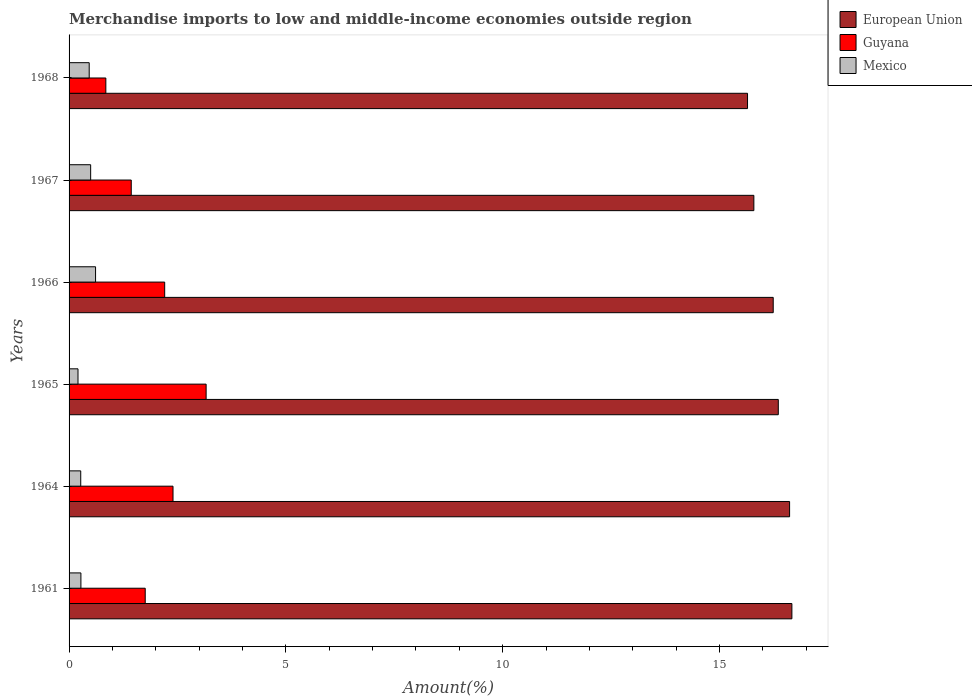How many different coloured bars are there?
Your answer should be compact. 3. How many groups of bars are there?
Your response must be concise. 6. Are the number of bars per tick equal to the number of legend labels?
Keep it short and to the point. Yes. Are the number of bars on each tick of the Y-axis equal?
Your answer should be very brief. Yes. How many bars are there on the 1st tick from the top?
Your response must be concise. 3. How many bars are there on the 5th tick from the bottom?
Give a very brief answer. 3. What is the label of the 4th group of bars from the top?
Make the answer very short. 1965. What is the percentage of amount earned from merchandise imports in Mexico in 1964?
Your answer should be compact. 0.27. Across all years, what is the maximum percentage of amount earned from merchandise imports in Guyana?
Offer a very short reply. 3.16. Across all years, what is the minimum percentage of amount earned from merchandise imports in Guyana?
Ensure brevity in your answer.  0.85. In which year was the percentage of amount earned from merchandise imports in Mexico minimum?
Ensure brevity in your answer.  1965. What is the total percentage of amount earned from merchandise imports in Mexico in the graph?
Give a very brief answer. 2.32. What is the difference between the percentage of amount earned from merchandise imports in European Union in 1964 and that in 1967?
Your answer should be very brief. 0.82. What is the difference between the percentage of amount earned from merchandise imports in Mexico in 1967 and the percentage of amount earned from merchandise imports in Guyana in 1965?
Provide a succinct answer. -2.66. What is the average percentage of amount earned from merchandise imports in European Union per year?
Offer a terse response. 16.22. In the year 1961, what is the difference between the percentage of amount earned from merchandise imports in Guyana and percentage of amount earned from merchandise imports in European Union?
Your response must be concise. -14.91. What is the ratio of the percentage of amount earned from merchandise imports in Mexico in 1964 to that in 1965?
Provide a short and direct response. 1.31. Is the percentage of amount earned from merchandise imports in Guyana in 1961 less than that in 1966?
Ensure brevity in your answer.  Yes. Is the difference between the percentage of amount earned from merchandise imports in Guyana in 1965 and 1968 greater than the difference between the percentage of amount earned from merchandise imports in European Union in 1965 and 1968?
Offer a very short reply. Yes. What is the difference between the highest and the second highest percentage of amount earned from merchandise imports in Mexico?
Your response must be concise. 0.11. What is the difference between the highest and the lowest percentage of amount earned from merchandise imports in European Union?
Your response must be concise. 1.02. In how many years, is the percentage of amount earned from merchandise imports in Guyana greater than the average percentage of amount earned from merchandise imports in Guyana taken over all years?
Ensure brevity in your answer.  3. Is the sum of the percentage of amount earned from merchandise imports in European Union in 1966 and 1967 greater than the maximum percentage of amount earned from merchandise imports in Mexico across all years?
Your response must be concise. Yes. What does the 2nd bar from the top in 1967 represents?
Your answer should be very brief. Guyana. Are all the bars in the graph horizontal?
Offer a terse response. Yes. Does the graph contain any zero values?
Offer a very short reply. No. Where does the legend appear in the graph?
Provide a short and direct response. Top right. What is the title of the graph?
Offer a very short reply. Merchandise imports to low and middle-income economies outside region. What is the label or title of the X-axis?
Provide a succinct answer. Amount(%). What is the Amount(%) of European Union in 1961?
Give a very brief answer. 16.67. What is the Amount(%) of Guyana in 1961?
Your answer should be compact. 1.76. What is the Amount(%) of Mexico in 1961?
Provide a short and direct response. 0.27. What is the Amount(%) in European Union in 1964?
Your answer should be very brief. 16.62. What is the Amount(%) in Guyana in 1964?
Make the answer very short. 2.4. What is the Amount(%) in Mexico in 1964?
Offer a very short reply. 0.27. What is the Amount(%) of European Union in 1965?
Offer a terse response. 16.36. What is the Amount(%) in Guyana in 1965?
Provide a short and direct response. 3.16. What is the Amount(%) in Mexico in 1965?
Your answer should be compact. 0.21. What is the Amount(%) in European Union in 1966?
Keep it short and to the point. 16.24. What is the Amount(%) in Guyana in 1966?
Make the answer very short. 2.21. What is the Amount(%) in Mexico in 1966?
Your answer should be very brief. 0.61. What is the Amount(%) of European Union in 1967?
Ensure brevity in your answer.  15.79. What is the Amount(%) in Guyana in 1967?
Ensure brevity in your answer.  1.43. What is the Amount(%) in Mexico in 1967?
Keep it short and to the point. 0.5. What is the Amount(%) in European Union in 1968?
Your response must be concise. 15.65. What is the Amount(%) in Guyana in 1968?
Make the answer very short. 0.85. What is the Amount(%) of Mexico in 1968?
Offer a terse response. 0.46. Across all years, what is the maximum Amount(%) of European Union?
Ensure brevity in your answer.  16.67. Across all years, what is the maximum Amount(%) in Guyana?
Ensure brevity in your answer.  3.16. Across all years, what is the maximum Amount(%) of Mexico?
Offer a very short reply. 0.61. Across all years, what is the minimum Amount(%) of European Union?
Make the answer very short. 15.65. Across all years, what is the minimum Amount(%) in Guyana?
Your answer should be compact. 0.85. Across all years, what is the minimum Amount(%) in Mexico?
Ensure brevity in your answer.  0.21. What is the total Amount(%) of European Union in the graph?
Make the answer very short. 97.33. What is the total Amount(%) in Guyana in the graph?
Provide a succinct answer. 11.8. What is the total Amount(%) in Mexico in the graph?
Your answer should be very brief. 2.32. What is the difference between the Amount(%) in European Union in 1961 and that in 1964?
Offer a very short reply. 0.05. What is the difference between the Amount(%) of Guyana in 1961 and that in 1964?
Keep it short and to the point. -0.64. What is the difference between the Amount(%) in Mexico in 1961 and that in 1964?
Offer a terse response. 0. What is the difference between the Amount(%) of European Union in 1961 and that in 1965?
Provide a short and direct response. 0.31. What is the difference between the Amount(%) in Guyana in 1961 and that in 1965?
Offer a very short reply. -1.4. What is the difference between the Amount(%) in Mexico in 1961 and that in 1965?
Ensure brevity in your answer.  0.07. What is the difference between the Amount(%) in European Union in 1961 and that in 1966?
Provide a short and direct response. 0.43. What is the difference between the Amount(%) of Guyana in 1961 and that in 1966?
Provide a succinct answer. -0.45. What is the difference between the Amount(%) in Mexico in 1961 and that in 1966?
Provide a succinct answer. -0.34. What is the difference between the Amount(%) in European Union in 1961 and that in 1967?
Keep it short and to the point. 0.88. What is the difference between the Amount(%) of Guyana in 1961 and that in 1967?
Offer a very short reply. 0.32. What is the difference between the Amount(%) of Mexico in 1961 and that in 1967?
Offer a terse response. -0.22. What is the difference between the Amount(%) of European Union in 1961 and that in 1968?
Your response must be concise. 1.02. What is the difference between the Amount(%) of Guyana in 1961 and that in 1968?
Your response must be concise. 0.91. What is the difference between the Amount(%) in Mexico in 1961 and that in 1968?
Ensure brevity in your answer.  -0.19. What is the difference between the Amount(%) of European Union in 1964 and that in 1965?
Ensure brevity in your answer.  0.26. What is the difference between the Amount(%) in Guyana in 1964 and that in 1965?
Make the answer very short. -0.76. What is the difference between the Amount(%) in Mexico in 1964 and that in 1965?
Provide a short and direct response. 0.06. What is the difference between the Amount(%) in European Union in 1964 and that in 1966?
Make the answer very short. 0.38. What is the difference between the Amount(%) in Guyana in 1964 and that in 1966?
Provide a short and direct response. 0.19. What is the difference between the Amount(%) of Mexico in 1964 and that in 1966?
Offer a terse response. -0.34. What is the difference between the Amount(%) in European Union in 1964 and that in 1967?
Keep it short and to the point. 0.82. What is the difference between the Amount(%) in Guyana in 1964 and that in 1967?
Your answer should be very brief. 0.96. What is the difference between the Amount(%) in Mexico in 1964 and that in 1967?
Give a very brief answer. -0.23. What is the difference between the Amount(%) in European Union in 1964 and that in 1968?
Keep it short and to the point. 0.97. What is the difference between the Amount(%) of Guyana in 1964 and that in 1968?
Your answer should be compact. 1.55. What is the difference between the Amount(%) of Mexico in 1964 and that in 1968?
Make the answer very short. -0.2. What is the difference between the Amount(%) in European Union in 1965 and that in 1966?
Keep it short and to the point. 0.12. What is the difference between the Amount(%) of Guyana in 1965 and that in 1966?
Provide a succinct answer. 0.96. What is the difference between the Amount(%) in Mexico in 1965 and that in 1966?
Your response must be concise. -0.4. What is the difference between the Amount(%) in European Union in 1965 and that in 1967?
Ensure brevity in your answer.  0.56. What is the difference between the Amount(%) of Guyana in 1965 and that in 1967?
Make the answer very short. 1.73. What is the difference between the Amount(%) in Mexico in 1965 and that in 1967?
Ensure brevity in your answer.  -0.29. What is the difference between the Amount(%) in European Union in 1965 and that in 1968?
Your response must be concise. 0.71. What is the difference between the Amount(%) of Guyana in 1965 and that in 1968?
Make the answer very short. 2.31. What is the difference between the Amount(%) in Mexico in 1965 and that in 1968?
Your answer should be very brief. -0.26. What is the difference between the Amount(%) in European Union in 1966 and that in 1967?
Make the answer very short. 0.45. What is the difference between the Amount(%) of Guyana in 1966 and that in 1967?
Provide a succinct answer. 0.77. What is the difference between the Amount(%) in Mexico in 1966 and that in 1967?
Your response must be concise. 0.11. What is the difference between the Amount(%) in European Union in 1966 and that in 1968?
Offer a terse response. 0.59. What is the difference between the Amount(%) in Guyana in 1966 and that in 1968?
Provide a succinct answer. 1.36. What is the difference between the Amount(%) in Mexico in 1966 and that in 1968?
Keep it short and to the point. 0.15. What is the difference between the Amount(%) in European Union in 1967 and that in 1968?
Provide a succinct answer. 0.15. What is the difference between the Amount(%) of Guyana in 1967 and that in 1968?
Ensure brevity in your answer.  0.59. What is the difference between the Amount(%) in Mexico in 1967 and that in 1968?
Your response must be concise. 0.03. What is the difference between the Amount(%) of European Union in 1961 and the Amount(%) of Guyana in 1964?
Your response must be concise. 14.27. What is the difference between the Amount(%) of European Union in 1961 and the Amount(%) of Mexico in 1964?
Provide a succinct answer. 16.4. What is the difference between the Amount(%) of Guyana in 1961 and the Amount(%) of Mexico in 1964?
Provide a short and direct response. 1.49. What is the difference between the Amount(%) in European Union in 1961 and the Amount(%) in Guyana in 1965?
Offer a very short reply. 13.51. What is the difference between the Amount(%) in European Union in 1961 and the Amount(%) in Mexico in 1965?
Your answer should be very brief. 16.47. What is the difference between the Amount(%) of Guyana in 1961 and the Amount(%) of Mexico in 1965?
Ensure brevity in your answer.  1.55. What is the difference between the Amount(%) of European Union in 1961 and the Amount(%) of Guyana in 1966?
Provide a short and direct response. 14.47. What is the difference between the Amount(%) in European Union in 1961 and the Amount(%) in Mexico in 1966?
Offer a terse response. 16.06. What is the difference between the Amount(%) of Guyana in 1961 and the Amount(%) of Mexico in 1966?
Ensure brevity in your answer.  1.15. What is the difference between the Amount(%) in European Union in 1961 and the Amount(%) in Guyana in 1967?
Offer a very short reply. 15.24. What is the difference between the Amount(%) of European Union in 1961 and the Amount(%) of Mexico in 1967?
Offer a terse response. 16.17. What is the difference between the Amount(%) of Guyana in 1961 and the Amount(%) of Mexico in 1967?
Provide a succinct answer. 1.26. What is the difference between the Amount(%) in European Union in 1961 and the Amount(%) in Guyana in 1968?
Offer a very short reply. 15.82. What is the difference between the Amount(%) of European Union in 1961 and the Amount(%) of Mexico in 1968?
Keep it short and to the point. 16.21. What is the difference between the Amount(%) in Guyana in 1961 and the Amount(%) in Mexico in 1968?
Your answer should be very brief. 1.29. What is the difference between the Amount(%) in European Union in 1964 and the Amount(%) in Guyana in 1965?
Keep it short and to the point. 13.46. What is the difference between the Amount(%) of European Union in 1964 and the Amount(%) of Mexico in 1965?
Your answer should be compact. 16.41. What is the difference between the Amount(%) of Guyana in 1964 and the Amount(%) of Mexico in 1965?
Provide a succinct answer. 2.19. What is the difference between the Amount(%) of European Union in 1964 and the Amount(%) of Guyana in 1966?
Provide a short and direct response. 14.41. What is the difference between the Amount(%) in European Union in 1964 and the Amount(%) in Mexico in 1966?
Keep it short and to the point. 16.01. What is the difference between the Amount(%) of Guyana in 1964 and the Amount(%) of Mexico in 1966?
Your response must be concise. 1.79. What is the difference between the Amount(%) in European Union in 1964 and the Amount(%) in Guyana in 1967?
Your answer should be compact. 15.18. What is the difference between the Amount(%) of European Union in 1964 and the Amount(%) of Mexico in 1967?
Your answer should be compact. 16.12. What is the difference between the Amount(%) in Guyana in 1964 and the Amount(%) in Mexico in 1967?
Offer a very short reply. 1.9. What is the difference between the Amount(%) in European Union in 1964 and the Amount(%) in Guyana in 1968?
Keep it short and to the point. 15.77. What is the difference between the Amount(%) in European Union in 1964 and the Amount(%) in Mexico in 1968?
Keep it short and to the point. 16.15. What is the difference between the Amount(%) in Guyana in 1964 and the Amount(%) in Mexico in 1968?
Your answer should be compact. 1.93. What is the difference between the Amount(%) in European Union in 1965 and the Amount(%) in Guyana in 1966?
Offer a terse response. 14.15. What is the difference between the Amount(%) in European Union in 1965 and the Amount(%) in Mexico in 1966?
Offer a terse response. 15.75. What is the difference between the Amount(%) in Guyana in 1965 and the Amount(%) in Mexico in 1966?
Your response must be concise. 2.55. What is the difference between the Amount(%) in European Union in 1965 and the Amount(%) in Guyana in 1967?
Keep it short and to the point. 14.92. What is the difference between the Amount(%) in European Union in 1965 and the Amount(%) in Mexico in 1967?
Make the answer very short. 15.86. What is the difference between the Amount(%) of Guyana in 1965 and the Amount(%) of Mexico in 1967?
Make the answer very short. 2.66. What is the difference between the Amount(%) of European Union in 1965 and the Amount(%) of Guyana in 1968?
Ensure brevity in your answer.  15.51. What is the difference between the Amount(%) of European Union in 1965 and the Amount(%) of Mexico in 1968?
Provide a succinct answer. 15.89. What is the difference between the Amount(%) of Guyana in 1965 and the Amount(%) of Mexico in 1968?
Offer a very short reply. 2.7. What is the difference between the Amount(%) in European Union in 1966 and the Amount(%) in Guyana in 1967?
Offer a very short reply. 14.81. What is the difference between the Amount(%) of European Union in 1966 and the Amount(%) of Mexico in 1967?
Your answer should be compact. 15.74. What is the difference between the Amount(%) of Guyana in 1966 and the Amount(%) of Mexico in 1967?
Your answer should be very brief. 1.71. What is the difference between the Amount(%) in European Union in 1966 and the Amount(%) in Guyana in 1968?
Make the answer very short. 15.39. What is the difference between the Amount(%) of European Union in 1966 and the Amount(%) of Mexico in 1968?
Provide a succinct answer. 15.78. What is the difference between the Amount(%) of Guyana in 1966 and the Amount(%) of Mexico in 1968?
Provide a short and direct response. 1.74. What is the difference between the Amount(%) in European Union in 1967 and the Amount(%) in Guyana in 1968?
Your answer should be compact. 14.95. What is the difference between the Amount(%) of European Union in 1967 and the Amount(%) of Mexico in 1968?
Your response must be concise. 15.33. What is the difference between the Amount(%) of Guyana in 1967 and the Amount(%) of Mexico in 1968?
Make the answer very short. 0.97. What is the average Amount(%) of European Union per year?
Keep it short and to the point. 16.22. What is the average Amount(%) in Guyana per year?
Provide a succinct answer. 1.97. What is the average Amount(%) in Mexico per year?
Make the answer very short. 0.39. In the year 1961, what is the difference between the Amount(%) in European Union and Amount(%) in Guyana?
Provide a short and direct response. 14.91. In the year 1961, what is the difference between the Amount(%) of European Union and Amount(%) of Mexico?
Your answer should be compact. 16.4. In the year 1961, what is the difference between the Amount(%) in Guyana and Amount(%) in Mexico?
Your answer should be very brief. 1.48. In the year 1964, what is the difference between the Amount(%) of European Union and Amount(%) of Guyana?
Provide a short and direct response. 14.22. In the year 1964, what is the difference between the Amount(%) of European Union and Amount(%) of Mexico?
Give a very brief answer. 16.35. In the year 1964, what is the difference between the Amount(%) of Guyana and Amount(%) of Mexico?
Make the answer very short. 2.13. In the year 1965, what is the difference between the Amount(%) in European Union and Amount(%) in Guyana?
Keep it short and to the point. 13.2. In the year 1965, what is the difference between the Amount(%) of European Union and Amount(%) of Mexico?
Your response must be concise. 16.15. In the year 1965, what is the difference between the Amount(%) of Guyana and Amount(%) of Mexico?
Provide a short and direct response. 2.95. In the year 1966, what is the difference between the Amount(%) of European Union and Amount(%) of Guyana?
Offer a very short reply. 14.04. In the year 1966, what is the difference between the Amount(%) in European Union and Amount(%) in Mexico?
Provide a short and direct response. 15.63. In the year 1966, what is the difference between the Amount(%) of Guyana and Amount(%) of Mexico?
Offer a very short reply. 1.59. In the year 1967, what is the difference between the Amount(%) of European Union and Amount(%) of Guyana?
Offer a very short reply. 14.36. In the year 1967, what is the difference between the Amount(%) in European Union and Amount(%) in Mexico?
Keep it short and to the point. 15.3. In the year 1967, what is the difference between the Amount(%) of Guyana and Amount(%) of Mexico?
Offer a very short reply. 0.94. In the year 1968, what is the difference between the Amount(%) of European Union and Amount(%) of Guyana?
Your answer should be compact. 14.8. In the year 1968, what is the difference between the Amount(%) of European Union and Amount(%) of Mexico?
Provide a succinct answer. 15.18. In the year 1968, what is the difference between the Amount(%) of Guyana and Amount(%) of Mexico?
Your response must be concise. 0.38. What is the ratio of the Amount(%) in European Union in 1961 to that in 1964?
Make the answer very short. 1. What is the ratio of the Amount(%) of Guyana in 1961 to that in 1964?
Your answer should be compact. 0.73. What is the ratio of the Amount(%) in Mexico in 1961 to that in 1964?
Your response must be concise. 1.01. What is the ratio of the Amount(%) in European Union in 1961 to that in 1965?
Your answer should be very brief. 1.02. What is the ratio of the Amount(%) of Guyana in 1961 to that in 1965?
Ensure brevity in your answer.  0.56. What is the ratio of the Amount(%) of Mexico in 1961 to that in 1965?
Offer a very short reply. 1.32. What is the ratio of the Amount(%) of European Union in 1961 to that in 1966?
Your answer should be very brief. 1.03. What is the ratio of the Amount(%) of Guyana in 1961 to that in 1966?
Your response must be concise. 0.8. What is the ratio of the Amount(%) in Mexico in 1961 to that in 1966?
Offer a terse response. 0.45. What is the ratio of the Amount(%) in European Union in 1961 to that in 1967?
Keep it short and to the point. 1.06. What is the ratio of the Amount(%) of Guyana in 1961 to that in 1967?
Your response must be concise. 1.22. What is the ratio of the Amount(%) in Mexico in 1961 to that in 1967?
Offer a very short reply. 0.55. What is the ratio of the Amount(%) in European Union in 1961 to that in 1968?
Your response must be concise. 1.07. What is the ratio of the Amount(%) of Guyana in 1961 to that in 1968?
Your response must be concise. 2.07. What is the ratio of the Amount(%) in Mexico in 1961 to that in 1968?
Your answer should be compact. 0.59. What is the ratio of the Amount(%) in European Union in 1964 to that in 1965?
Offer a very short reply. 1.02. What is the ratio of the Amount(%) in Guyana in 1964 to that in 1965?
Your answer should be compact. 0.76. What is the ratio of the Amount(%) of Mexico in 1964 to that in 1965?
Your answer should be compact. 1.31. What is the ratio of the Amount(%) of European Union in 1964 to that in 1966?
Provide a short and direct response. 1.02. What is the ratio of the Amount(%) in Guyana in 1964 to that in 1966?
Keep it short and to the point. 1.09. What is the ratio of the Amount(%) in Mexico in 1964 to that in 1966?
Give a very brief answer. 0.44. What is the ratio of the Amount(%) in European Union in 1964 to that in 1967?
Provide a succinct answer. 1.05. What is the ratio of the Amount(%) of Guyana in 1964 to that in 1967?
Your response must be concise. 1.67. What is the ratio of the Amount(%) of Mexico in 1964 to that in 1967?
Your answer should be compact. 0.54. What is the ratio of the Amount(%) of European Union in 1964 to that in 1968?
Your response must be concise. 1.06. What is the ratio of the Amount(%) of Guyana in 1964 to that in 1968?
Offer a terse response. 2.83. What is the ratio of the Amount(%) of Mexico in 1964 to that in 1968?
Provide a short and direct response. 0.58. What is the ratio of the Amount(%) in European Union in 1965 to that in 1966?
Your response must be concise. 1.01. What is the ratio of the Amount(%) of Guyana in 1965 to that in 1966?
Offer a very short reply. 1.43. What is the ratio of the Amount(%) in Mexico in 1965 to that in 1966?
Make the answer very short. 0.34. What is the ratio of the Amount(%) of European Union in 1965 to that in 1967?
Give a very brief answer. 1.04. What is the ratio of the Amount(%) in Guyana in 1965 to that in 1967?
Ensure brevity in your answer.  2.2. What is the ratio of the Amount(%) in Mexico in 1965 to that in 1967?
Offer a terse response. 0.41. What is the ratio of the Amount(%) of European Union in 1965 to that in 1968?
Make the answer very short. 1.05. What is the ratio of the Amount(%) in Guyana in 1965 to that in 1968?
Give a very brief answer. 3.73. What is the ratio of the Amount(%) of Mexico in 1965 to that in 1968?
Give a very brief answer. 0.44. What is the ratio of the Amount(%) in European Union in 1966 to that in 1967?
Ensure brevity in your answer.  1.03. What is the ratio of the Amount(%) of Guyana in 1966 to that in 1967?
Your response must be concise. 1.54. What is the ratio of the Amount(%) in Mexico in 1966 to that in 1967?
Provide a short and direct response. 1.23. What is the ratio of the Amount(%) of European Union in 1966 to that in 1968?
Your response must be concise. 1.04. What is the ratio of the Amount(%) in Guyana in 1966 to that in 1968?
Give a very brief answer. 2.6. What is the ratio of the Amount(%) in Mexico in 1966 to that in 1968?
Ensure brevity in your answer.  1.32. What is the ratio of the Amount(%) of European Union in 1967 to that in 1968?
Keep it short and to the point. 1.01. What is the ratio of the Amount(%) of Guyana in 1967 to that in 1968?
Provide a short and direct response. 1.69. What is the ratio of the Amount(%) of Mexico in 1967 to that in 1968?
Offer a terse response. 1.07. What is the difference between the highest and the second highest Amount(%) of European Union?
Provide a succinct answer. 0.05. What is the difference between the highest and the second highest Amount(%) in Guyana?
Make the answer very short. 0.76. What is the difference between the highest and the second highest Amount(%) in Mexico?
Offer a very short reply. 0.11. What is the difference between the highest and the lowest Amount(%) of European Union?
Give a very brief answer. 1.02. What is the difference between the highest and the lowest Amount(%) in Guyana?
Your response must be concise. 2.31. What is the difference between the highest and the lowest Amount(%) in Mexico?
Provide a succinct answer. 0.4. 